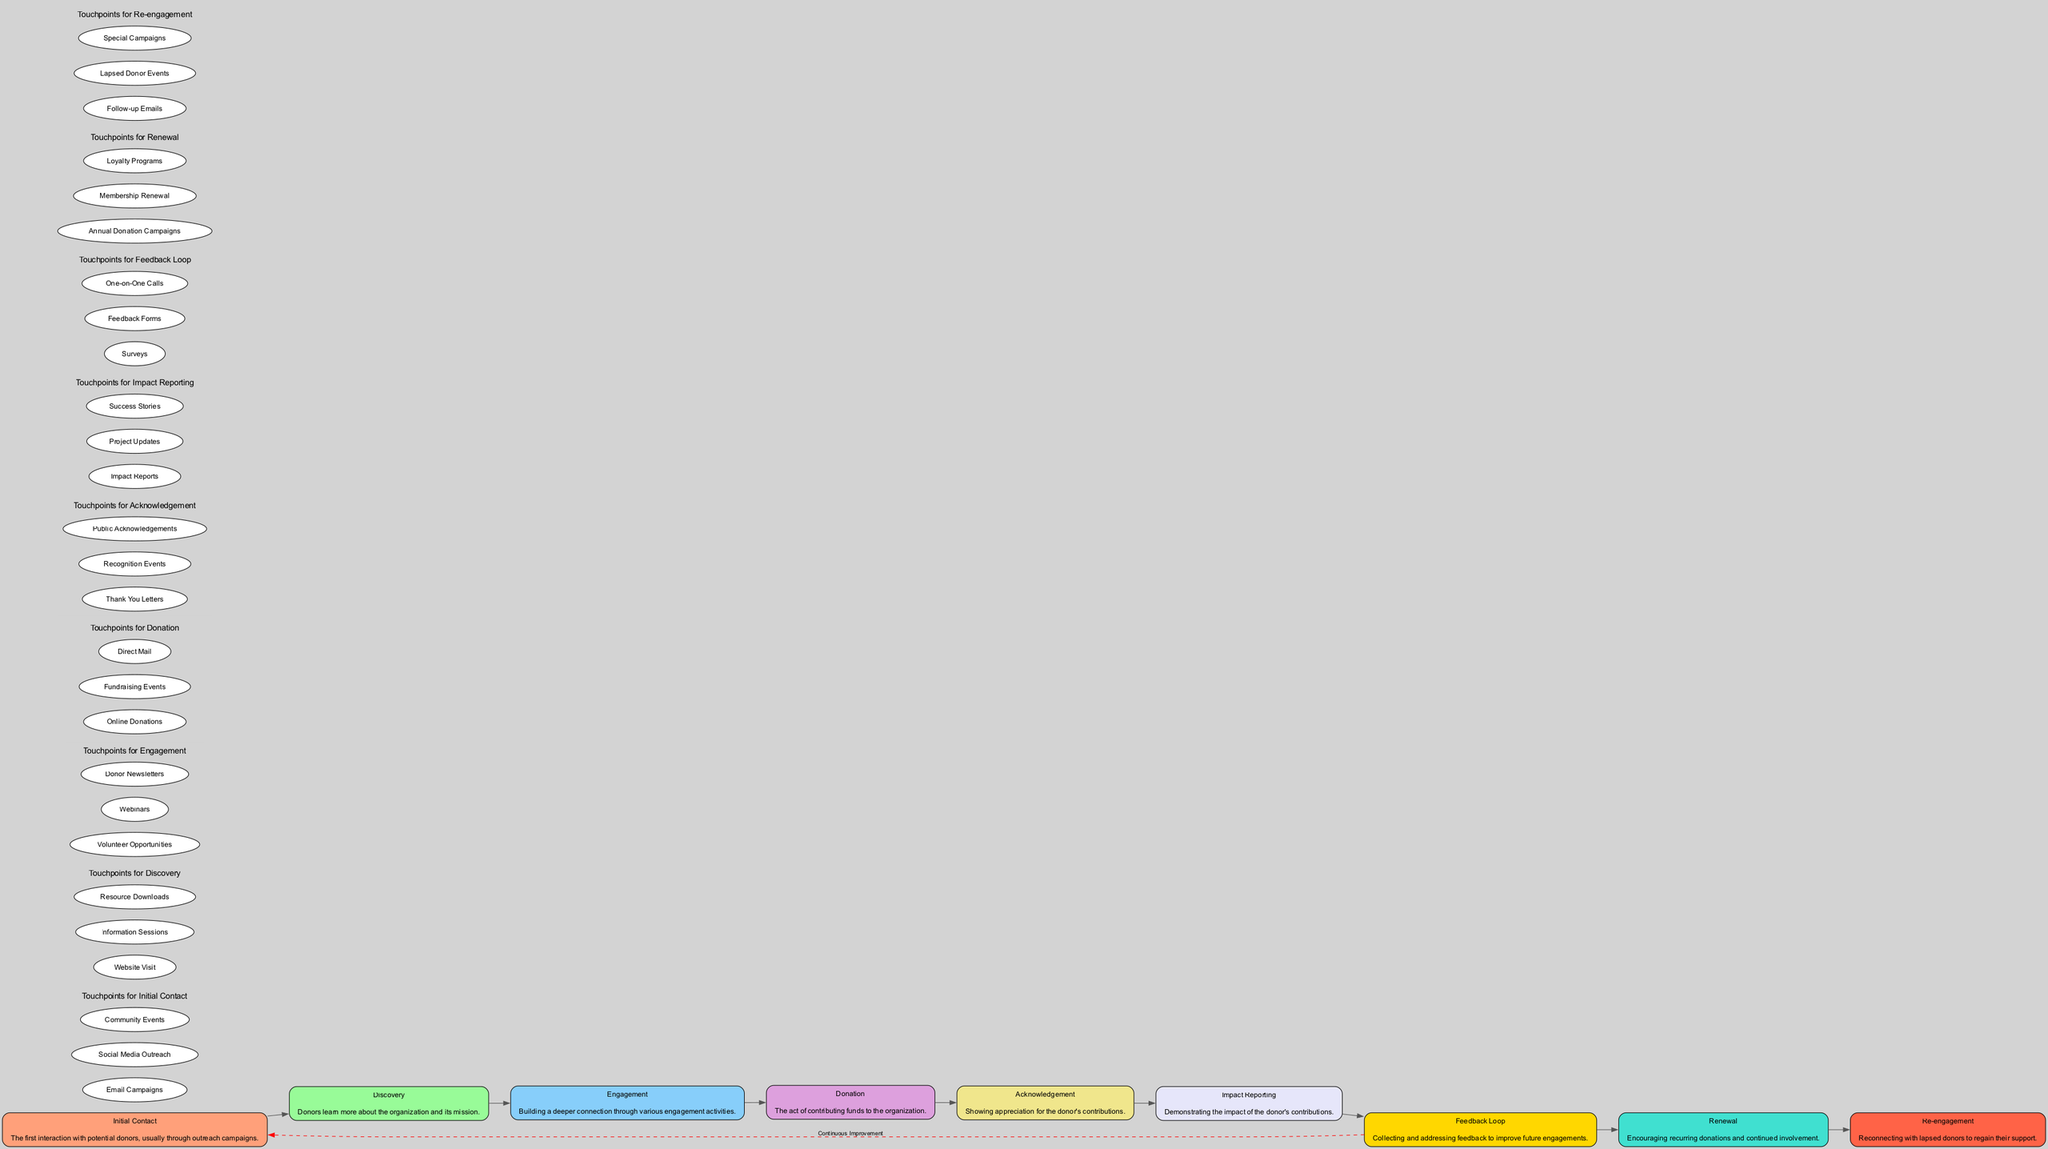What is the first phase in the donor engagement journey? The diagram starts with the "Initial Contact" phase, which is the first interaction with potential donors.
Answer: Initial Contact How many touchpoints are listed under the "Engagement" phase? The "Engagement" phase has three specific touchpoints listed: Volunteer Opportunities, Webinars, and Donor Newsletters.
Answer: 3 Which node follows the "Acknowledgement" phase? Following the "Acknowledgement" phase in the diagram is the "Impact Reporting" phase. This indicates the sequence in the donor engagement journey.
Answer: Impact Reporting What type of connection does the "Feedback Loop" create with the "Initial Contact"? The "Feedback Loop" creates a dashed edge to the "Initial Contact," indicating a continuous improvement strategy that connects donor feedback back to the initial outreach efforts.
Answer: Continuous Improvement How many main nodes are in the diagram? The diagram contains nine main nodes that represent different phases in the donor engagement journey.
Answer: 9 What is the last phase before "Renewal"? The phase directly preceding "Renewal" in the engagement journey is "Re-engagement," indicating efforts to reconnect with lapsed donors.
Answer: Re-engagement What do the entities under each phase represent? The entities under each phase represent specific touchpoints through which donor interactions and engagement occur, such as outreach campaigns or events.
Answer: Touchpoints How does the "Feedback Loop" impact the overall journey? The "Feedback Loop" serves to create a connection that allows for continuous improvement in strategies based on donor feedback, enhancing future touchpoints.
Answer: Continuous Improvement What color is used for the "Donation" phase? The "Donation" phase is represented using a light purple color, according to the color palette specified in the diagram.
Answer: Light Purple 